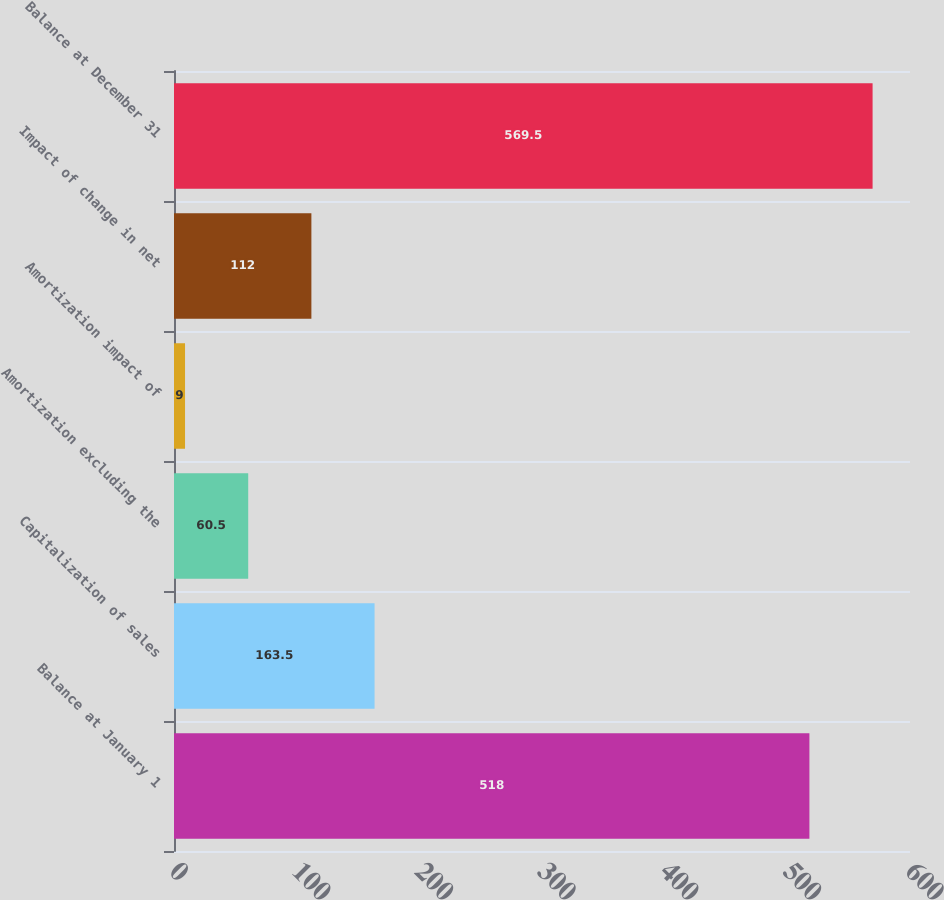Convert chart. <chart><loc_0><loc_0><loc_500><loc_500><bar_chart><fcel>Balance at January 1<fcel>Capitalization of sales<fcel>Amortization excluding the<fcel>Amortization impact of<fcel>Impact of change in net<fcel>Balance at December 31<nl><fcel>518<fcel>163.5<fcel>60.5<fcel>9<fcel>112<fcel>569.5<nl></chart> 